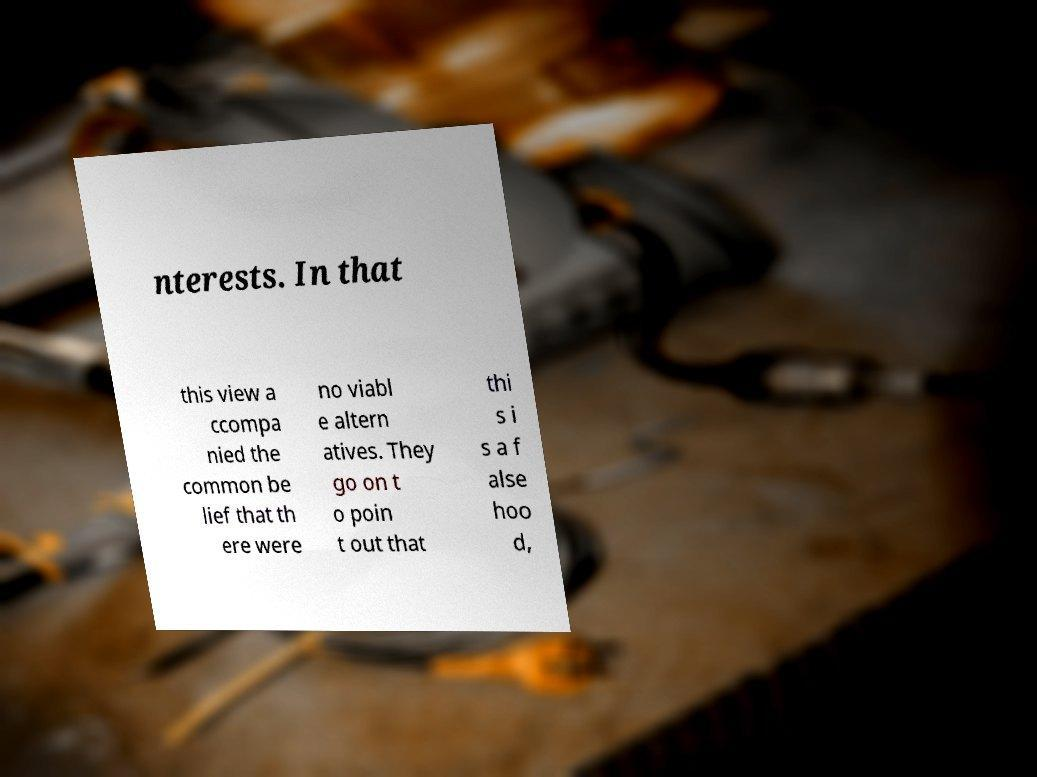Please read and relay the text visible in this image. What does it say? nterests. In that this view a ccompa nied the common be lief that th ere were no viabl e altern atives. They go on t o poin t out that thi s i s a f alse hoo d, 